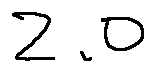Convert formula to latex. <formula><loc_0><loc_0><loc_500><loc_500>2 . 0</formula> 